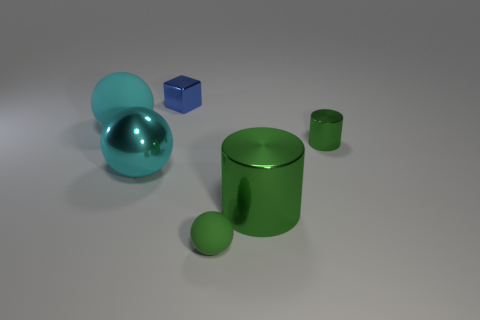What number of blue shiny cubes are to the left of the large cyan thing on the right side of the rubber ball left of the tiny blue shiny thing?
Ensure brevity in your answer.  0. How many spheres are either brown rubber things or big things?
Your response must be concise. 2. There is a matte sphere in front of the matte ball that is behind the small green object to the left of the large metallic cylinder; what color is it?
Offer a very short reply. Green. What number of other objects are there of the same size as the cyan rubber thing?
Provide a succinct answer. 2. Is there anything else that has the same shape as the tiny blue object?
Ensure brevity in your answer.  No. What is the color of the other thing that is the same shape as the tiny green metal object?
Keep it short and to the point. Green. What color is the ball that is the same material as the tiny block?
Your answer should be compact. Cyan. Are there the same number of big cyan balls that are on the right side of the tiny green ball and shiny objects?
Your answer should be compact. No. Do the rubber sphere that is to the left of the green rubber ball and the blue metal block have the same size?
Give a very brief answer. No. There is a matte object that is the same size as the cyan metallic object; what is its color?
Offer a very short reply. Cyan. 